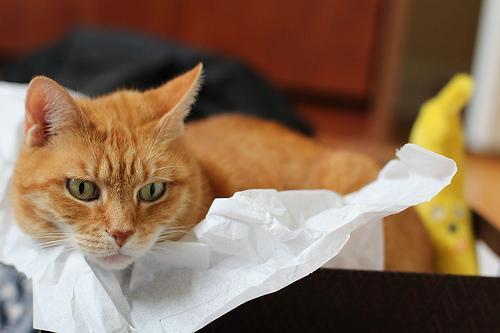How many kind animals are in the photo?
Give a very brief answer. 1. 